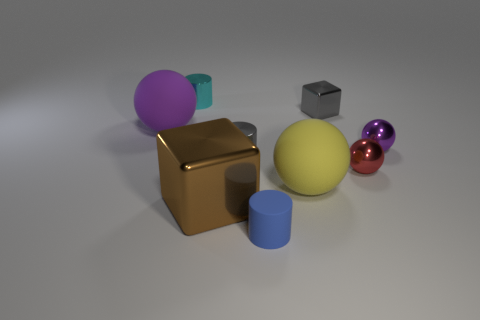The other matte thing that is the same shape as the yellow rubber object is what color?
Keep it short and to the point. Purple. What is the size of the purple rubber object that is the same shape as the red metallic thing?
Ensure brevity in your answer.  Large. Are there an equal number of big matte objects in front of the big purple matte object and purple things?
Your answer should be compact. No. What is the size of the blue matte cylinder?
Offer a terse response. Small. There is a object that is the same color as the tiny block; what is it made of?
Your response must be concise. Metal. What number of tiny cylinders have the same color as the tiny shiny block?
Your answer should be very brief. 1. Do the gray cylinder and the purple shiny ball have the same size?
Your answer should be compact. Yes. There is a block to the right of the large rubber thing that is right of the brown cube; what size is it?
Offer a very short reply. Small. Is the color of the rubber cylinder the same as the big object right of the blue cylinder?
Your response must be concise. No. Are there any blue things that have the same size as the red metallic sphere?
Offer a terse response. Yes. 